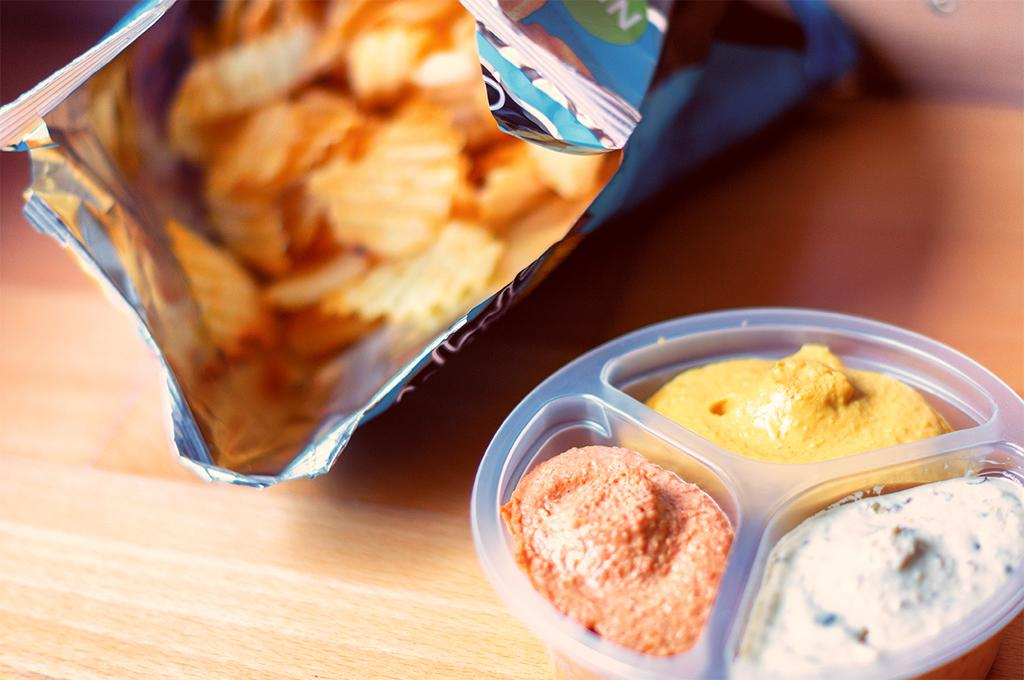What type of food item is in the packet in the image? There is a chips packet in the image, but the specific type of chips is not mentioned. What is in the bowl in the image? There is a bowl with food items in the image. On what surface are the bowl and chips packet placed? The bowl and chips packet are placed on a wooden table. How many frogs are sitting on the prose in the image? There are no frogs or prose present in the image. 